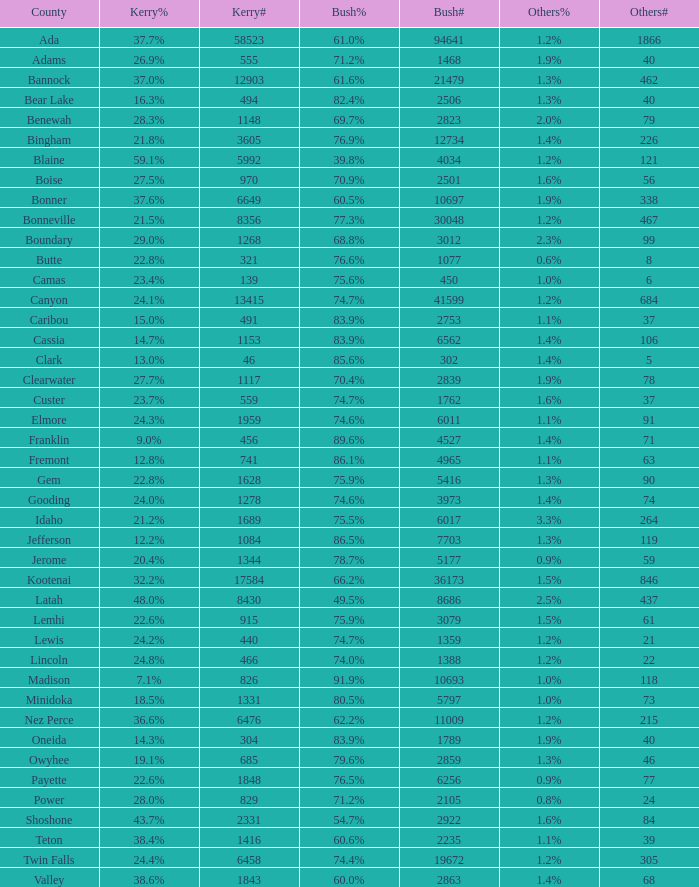What was the number of votes kerry received in the county where 8 votes were given to other candidates? 321.0. Give me the full table as a dictionary. {'header': ['County', 'Kerry%', 'Kerry#', 'Bush%', 'Bush#', 'Others%', 'Others#'], 'rows': [['Ada', '37.7%', '58523', '61.0%', '94641', '1.2%', '1866'], ['Adams', '26.9%', '555', '71.2%', '1468', '1.9%', '40'], ['Bannock', '37.0%', '12903', '61.6%', '21479', '1.3%', '462'], ['Bear Lake', '16.3%', '494', '82.4%', '2506', '1.3%', '40'], ['Benewah', '28.3%', '1148', '69.7%', '2823', '2.0%', '79'], ['Bingham', '21.8%', '3605', '76.9%', '12734', '1.4%', '226'], ['Blaine', '59.1%', '5992', '39.8%', '4034', '1.2%', '121'], ['Boise', '27.5%', '970', '70.9%', '2501', '1.6%', '56'], ['Bonner', '37.6%', '6649', '60.5%', '10697', '1.9%', '338'], ['Bonneville', '21.5%', '8356', '77.3%', '30048', '1.2%', '467'], ['Boundary', '29.0%', '1268', '68.8%', '3012', '2.3%', '99'], ['Butte', '22.8%', '321', '76.6%', '1077', '0.6%', '8'], ['Camas', '23.4%', '139', '75.6%', '450', '1.0%', '6'], ['Canyon', '24.1%', '13415', '74.7%', '41599', '1.2%', '684'], ['Caribou', '15.0%', '491', '83.9%', '2753', '1.1%', '37'], ['Cassia', '14.7%', '1153', '83.9%', '6562', '1.4%', '106'], ['Clark', '13.0%', '46', '85.6%', '302', '1.4%', '5'], ['Clearwater', '27.7%', '1117', '70.4%', '2839', '1.9%', '78'], ['Custer', '23.7%', '559', '74.7%', '1762', '1.6%', '37'], ['Elmore', '24.3%', '1959', '74.6%', '6011', '1.1%', '91'], ['Franklin', '9.0%', '456', '89.6%', '4527', '1.4%', '71'], ['Fremont', '12.8%', '741', '86.1%', '4965', '1.1%', '63'], ['Gem', '22.8%', '1628', '75.9%', '5416', '1.3%', '90'], ['Gooding', '24.0%', '1278', '74.6%', '3973', '1.4%', '74'], ['Idaho', '21.2%', '1689', '75.5%', '6017', '3.3%', '264'], ['Jefferson', '12.2%', '1084', '86.5%', '7703', '1.3%', '119'], ['Jerome', '20.4%', '1344', '78.7%', '5177', '0.9%', '59'], ['Kootenai', '32.2%', '17584', '66.2%', '36173', '1.5%', '846'], ['Latah', '48.0%', '8430', '49.5%', '8686', '2.5%', '437'], ['Lemhi', '22.6%', '915', '75.9%', '3079', '1.5%', '61'], ['Lewis', '24.2%', '440', '74.7%', '1359', '1.2%', '21'], ['Lincoln', '24.8%', '466', '74.0%', '1388', '1.2%', '22'], ['Madison', '7.1%', '826', '91.9%', '10693', '1.0%', '118'], ['Minidoka', '18.5%', '1331', '80.5%', '5797', '1.0%', '73'], ['Nez Perce', '36.6%', '6476', '62.2%', '11009', '1.2%', '215'], ['Oneida', '14.3%', '304', '83.9%', '1789', '1.9%', '40'], ['Owyhee', '19.1%', '685', '79.6%', '2859', '1.3%', '46'], ['Payette', '22.6%', '1848', '76.5%', '6256', '0.9%', '77'], ['Power', '28.0%', '829', '71.2%', '2105', '0.8%', '24'], ['Shoshone', '43.7%', '2331', '54.7%', '2922', '1.6%', '84'], ['Teton', '38.4%', '1416', '60.6%', '2235', '1.1%', '39'], ['Twin Falls', '24.4%', '6458', '74.4%', '19672', '1.2%', '305'], ['Valley', '38.6%', '1843', '60.0%', '2863', '1.4%', '68']]} 